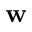Convert formula to latex. <formula><loc_0><loc_0><loc_500><loc_500>w</formula> 